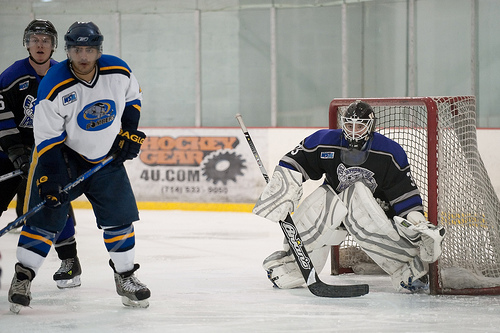<image>
Is there a helmet on the man? Yes. Looking at the image, I can see the helmet is positioned on top of the man, with the man providing support. 